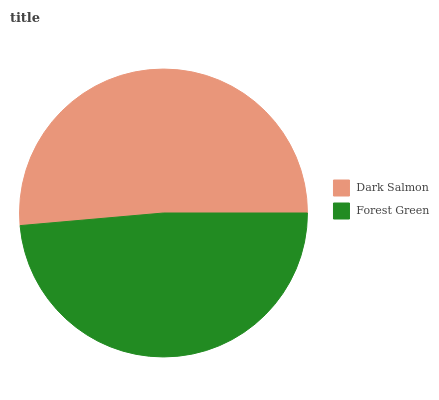Is Forest Green the minimum?
Answer yes or no. Yes. Is Dark Salmon the maximum?
Answer yes or no. Yes. Is Forest Green the maximum?
Answer yes or no. No. Is Dark Salmon greater than Forest Green?
Answer yes or no. Yes. Is Forest Green less than Dark Salmon?
Answer yes or no. Yes. Is Forest Green greater than Dark Salmon?
Answer yes or no. No. Is Dark Salmon less than Forest Green?
Answer yes or no. No. Is Dark Salmon the high median?
Answer yes or no. Yes. Is Forest Green the low median?
Answer yes or no. Yes. Is Forest Green the high median?
Answer yes or no. No. Is Dark Salmon the low median?
Answer yes or no. No. 